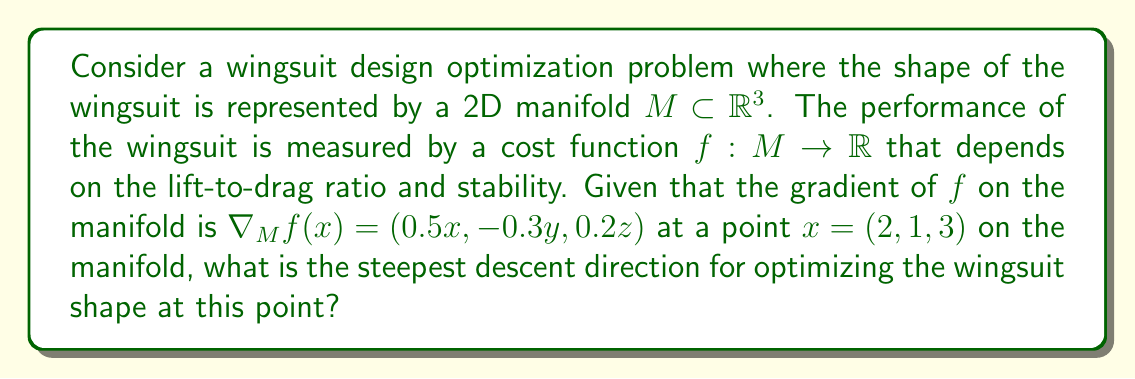What is the answer to this math problem? To solve this problem, we need to follow these steps:

1) In manifold optimization, the steepest descent direction is given by the negative of the Riemannian gradient. The Riemannian gradient is the projection of the Euclidean gradient onto the tangent space of the manifold at the given point.

2) We are given the gradient of $f$ on the manifold:

   $\nabla_M f(x) = (0.5x, -0.3y, 0.2z) = (1, -0.3, 0.6)$ at $x = (2, 1, 3)$

3) Since we're not given any information about the specific geometry of the manifold, we can assume that the tangent space at this point coincides with the Euclidean space. In this case, the Riemannian gradient is the same as the Euclidean gradient.

4) The steepest descent direction is the negative of this gradient:

   $-\nabla_M f(x) = (-1, 0.3, -0.6)$

5) To get a unit vector in this direction (which is typically used in optimization algorithms), we need to normalize this vector:

   $\text{Steepest descent direction} = \frac{(-1, 0.3, -0.6)}{\sqrt{(-1)^2 + 0.3^2 + (-0.6)^2}} = \frac{(-1, 0.3, -0.6)}{\sqrt{1 + 0.09 + 0.36}} = \frac{(-1, 0.3, -0.6)}{\sqrt{1.45}}$
Answer: The steepest descent direction for optimizing the wingsuit shape at the given point is:

$$\frac{(-1, 0.3, -0.6)}{\sqrt{1.45}} \approx (-0.831, 0.249, -0.498)$$ 